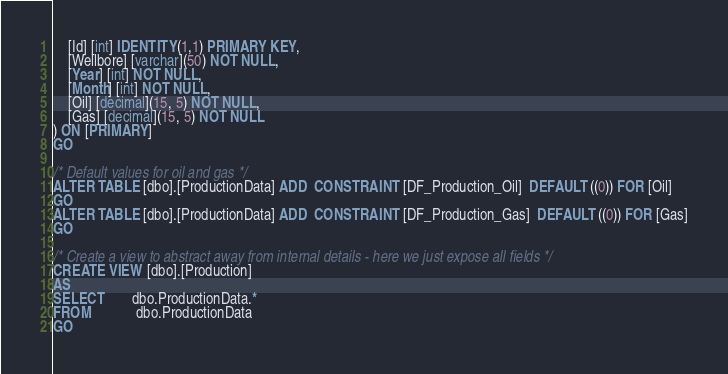<code> <loc_0><loc_0><loc_500><loc_500><_SQL_>	[Id] [int] IDENTITY(1,1) PRIMARY KEY,
	[Wellbore] [varchar](50) NOT NULL,
	[Year] [int] NOT NULL,
	[Month] [int] NOT NULL,
	[Oil] [decimal](15, 5) NOT NULL,
	[Gas] [decimal](15, 5) NOT NULL
) ON [PRIMARY]
GO

/* Default values for oil and gas */
ALTER TABLE [dbo].[ProductionData] ADD  CONSTRAINT [DF_Production_Oil]  DEFAULT ((0)) FOR [Oil]
GO
ALTER TABLE [dbo].[ProductionData] ADD  CONSTRAINT [DF_Production_Gas]  DEFAULT ((0)) FOR [Gas]
GO

/* Create a view to abstract away from internal details - here we just expose all fields */
CREATE VIEW [dbo].[Production]
AS
SELECT        dbo.ProductionData.*
FROM            dbo.ProductionData
GO

</code> 